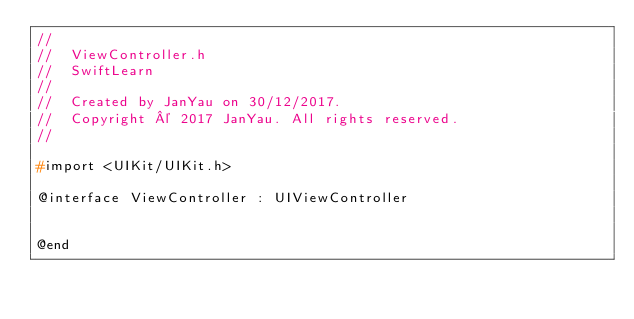Convert code to text. <code><loc_0><loc_0><loc_500><loc_500><_C_>//
//  ViewController.h
//  SwiftLearn
//
//  Created by JanYau on 30/12/2017.
//  Copyright © 2017 JanYau. All rights reserved.
//

#import <UIKit/UIKit.h>

@interface ViewController : UIViewController


@end

</code> 